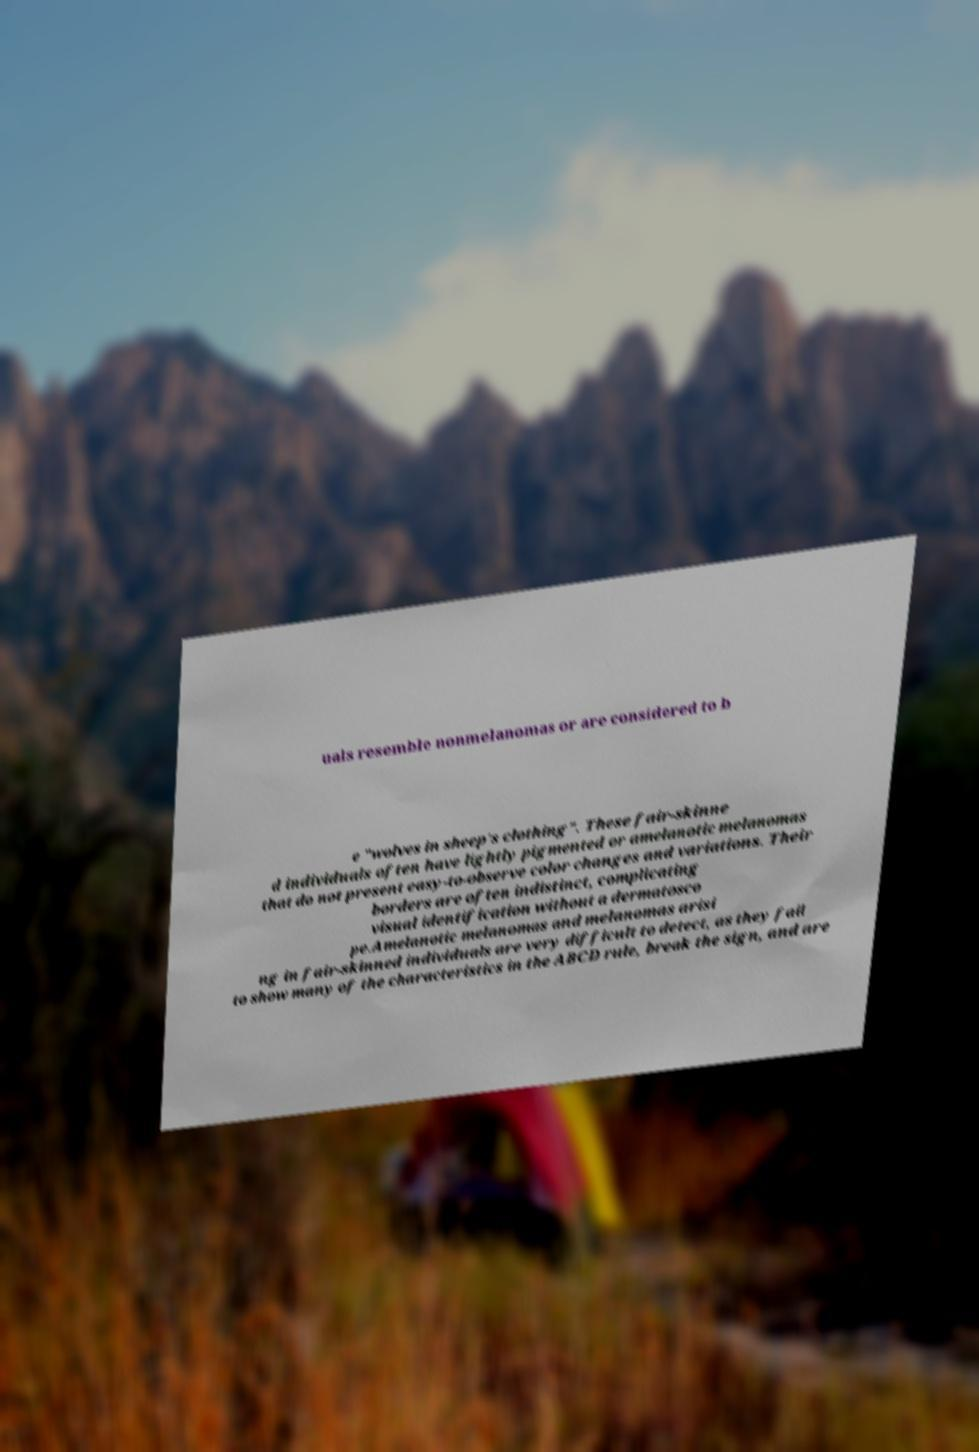For documentation purposes, I need the text within this image transcribed. Could you provide that? uals resemble nonmelanomas or are considered to b e "wolves in sheep's clothing". These fair-skinne d individuals often have lightly pigmented or amelanotic melanomas that do not present easy-to-observe color changes and variations. Their borders are often indistinct, complicating visual identification without a dermatosco pe.Amelanotic melanomas and melanomas arisi ng in fair-skinned individuals are very difficult to detect, as they fail to show many of the characteristics in the ABCD rule, break the sign, and are 